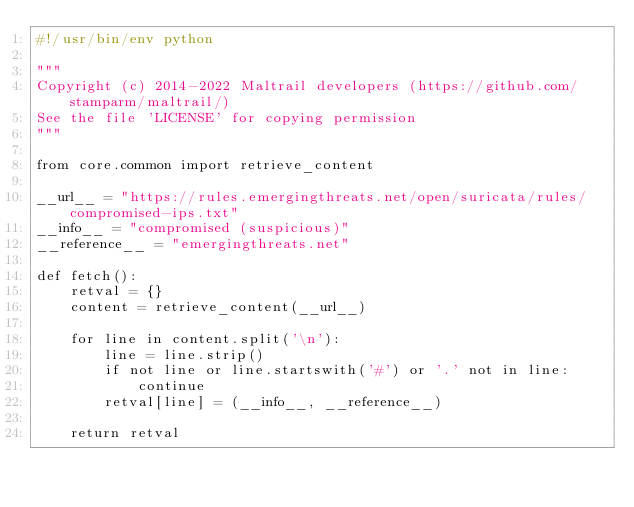<code> <loc_0><loc_0><loc_500><loc_500><_Python_>#!/usr/bin/env python

"""
Copyright (c) 2014-2022 Maltrail developers (https://github.com/stamparm/maltrail/)
See the file 'LICENSE' for copying permission
"""

from core.common import retrieve_content

__url__ = "https://rules.emergingthreats.net/open/suricata/rules/compromised-ips.txt"
__info__ = "compromised (suspicious)"
__reference__ = "emergingthreats.net"

def fetch():
    retval = {}
    content = retrieve_content(__url__)

    for line in content.split('\n'):
        line = line.strip()
        if not line or line.startswith('#') or '.' not in line:
            continue
        retval[line] = (__info__, __reference__)

    return retval
</code> 